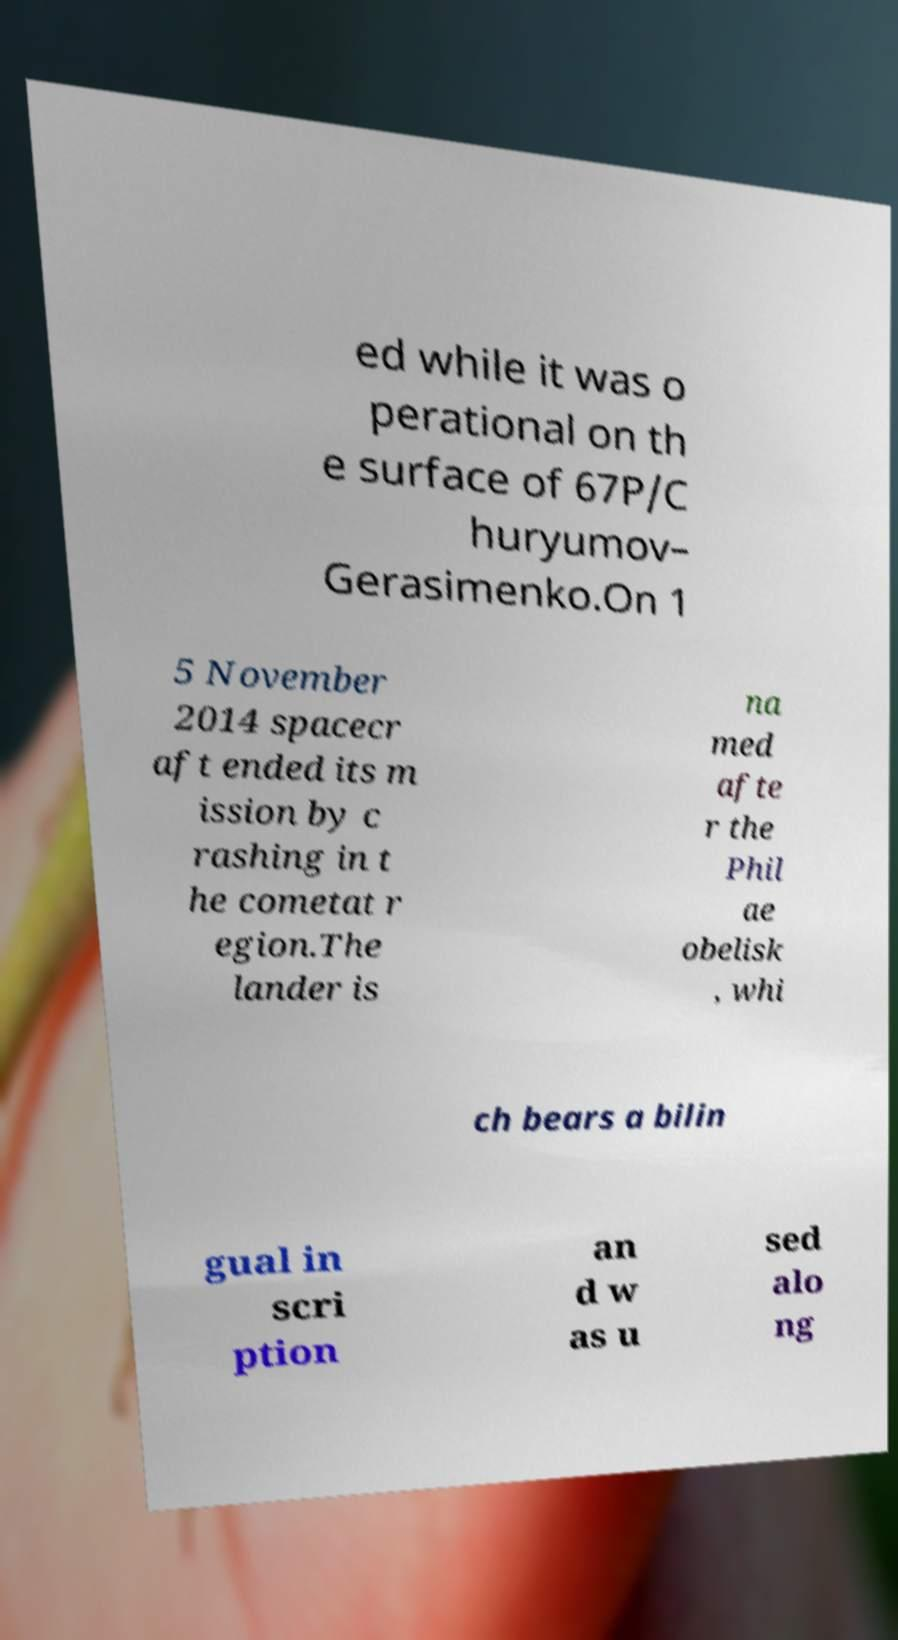There's text embedded in this image that I need extracted. Can you transcribe it verbatim? ed while it was o perational on th e surface of 67P/C huryumov– Gerasimenko.On 1 5 November 2014 spacecr aft ended its m ission by c rashing in t he cometat r egion.The lander is na med afte r the Phil ae obelisk , whi ch bears a bilin gual in scri ption an d w as u sed alo ng 